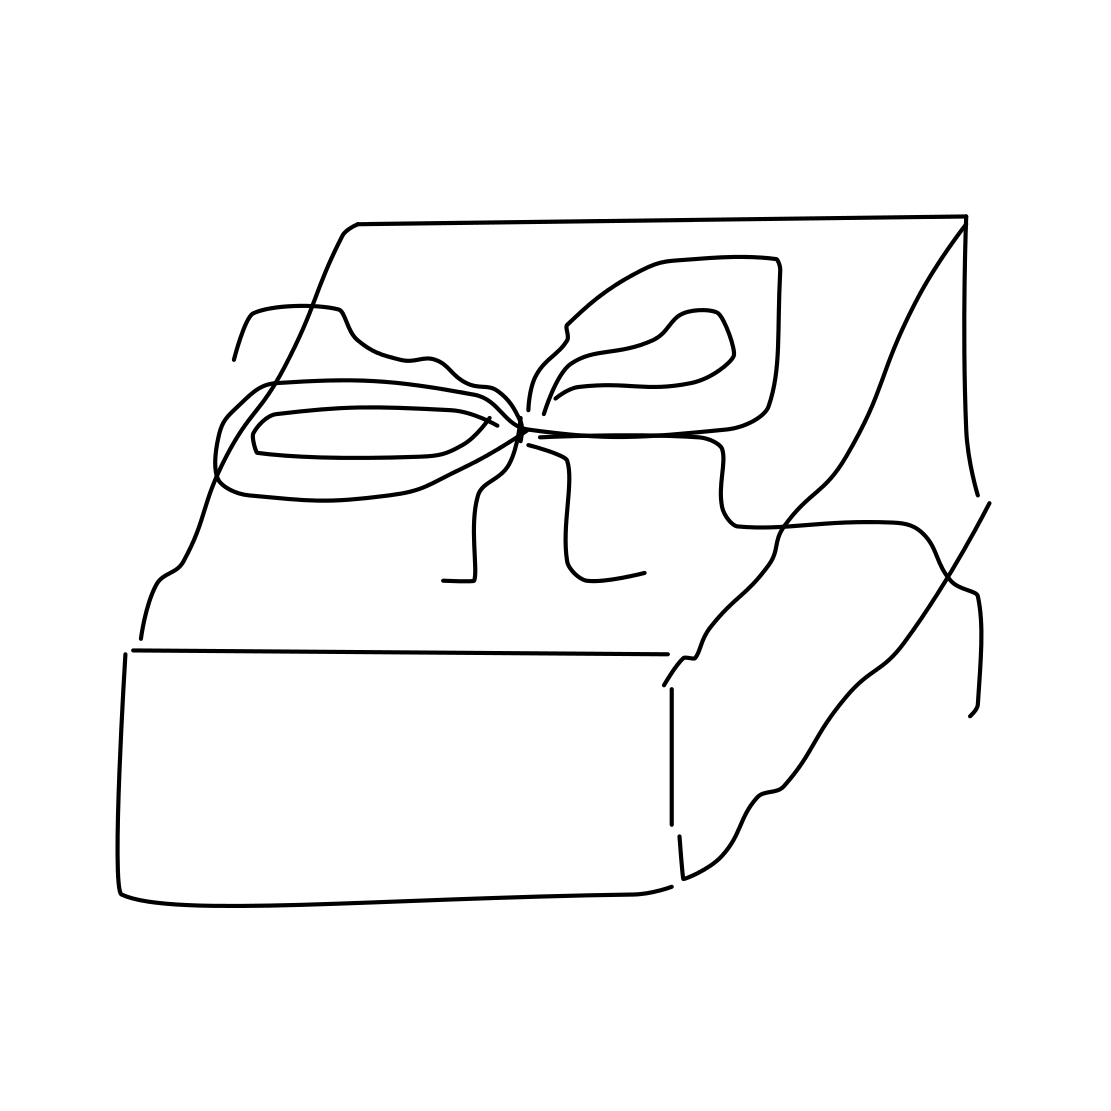Is this a present in the image? Yes, there is a present in the image. It's depicted with a simple ribbon and appears to be enclosed in a box, suggestive of a typical gift-wrapping style. 